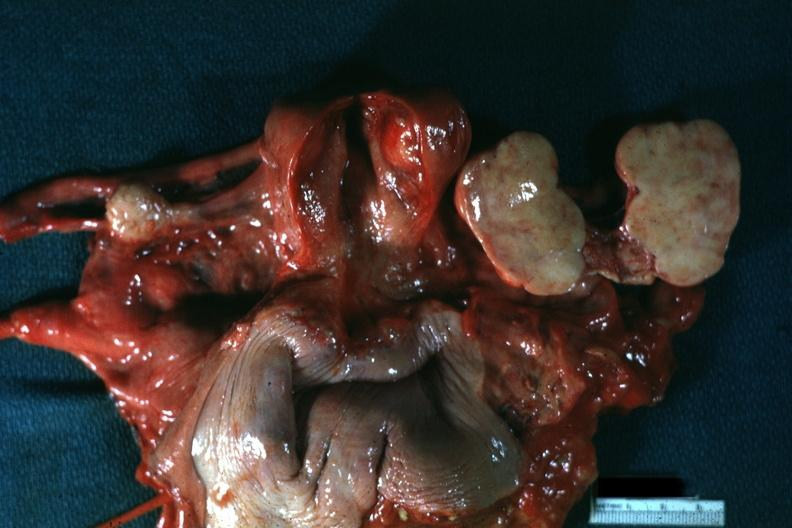where does this belong to?
Answer the question using a single word or phrase. Female reproductive system 